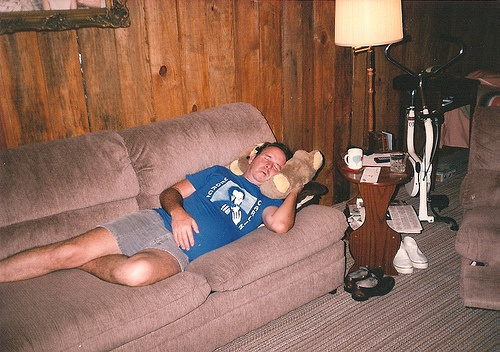Describe the objects in this image and their specific colors. I can see couch in darkgray, gray, lightpink, salmon, and brown tones, people in darkgray, blue, salmon, and brown tones, couch in darkgray, brown, gray, maroon, and black tones, teddy bear in darkgray, gray, tan, and salmon tones, and cup in darkgray, ivory, gray, and lightgray tones in this image. 